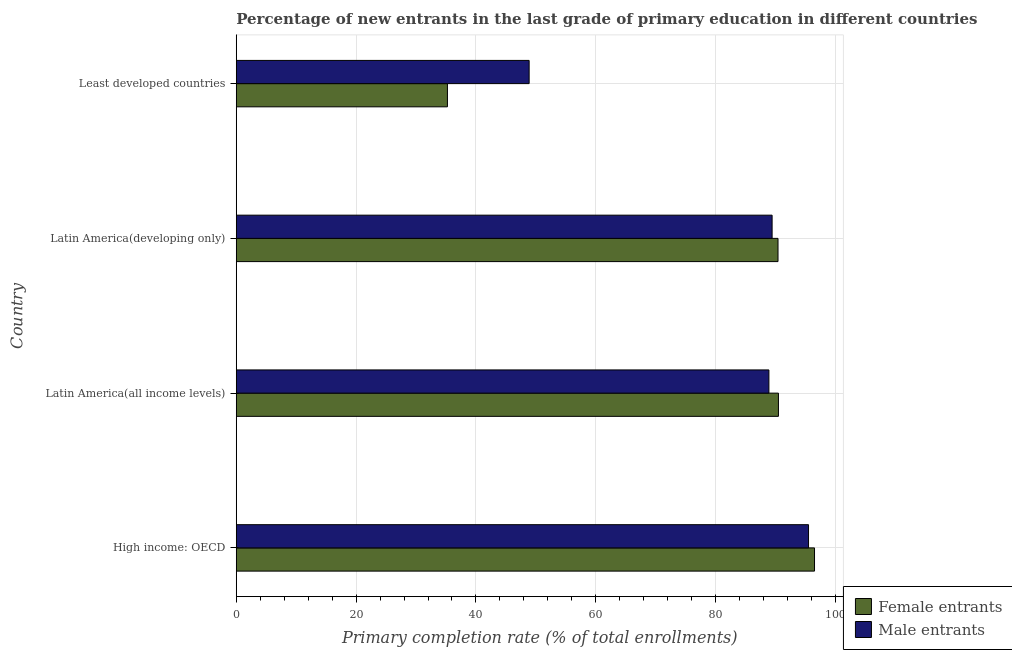How many different coloured bars are there?
Provide a succinct answer. 2. Are the number of bars on each tick of the Y-axis equal?
Your response must be concise. Yes. How many bars are there on the 1st tick from the top?
Provide a short and direct response. 2. What is the label of the 3rd group of bars from the top?
Provide a succinct answer. Latin America(all income levels). In how many cases, is the number of bars for a given country not equal to the number of legend labels?
Keep it short and to the point. 0. What is the primary completion rate of male entrants in Latin America(developing only)?
Provide a succinct answer. 89.42. Across all countries, what is the maximum primary completion rate of female entrants?
Keep it short and to the point. 96.5. Across all countries, what is the minimum primary completion rate of male entrants?
Provide a succinct answer. 48.88. In which country was the primary completion rate of female entrants maximum?
Make the answer very short. High income: OECD. In which country was the primary completion rate of female entrants minimum?
Your response must be concise. Least developed countries. What is the total primary completion rate of male entrants in the graph?
Provide a succinct answer. 322.68. What is the difference between the primary completion rate of female entrants in High income: OECD and that in Latin America(developing only)?
Give a very brief answer. 6.09. What is the difference between the primary completion rate of female entrants in High income: OECD and the primary completion rate of male entrants in Latin America(all income levels)?
Ensure brevity in your answer.  7.61. What is the average primary completion rate of male entrants per country?
Your response must be concise. 80.67. What is the difference between the primary completion rate of female entrants and primary completion rate of male entrants in Least developed countries?
Your answer should be compact. -13.63. What is the ratio of the primary completion rate of female entrants in High income: OECD to that in Latin America(developing only)?
Ensure brevity in your answer.  1.07. Is the primary completion rate of female entrants in High income: OECD less than that in Latin America(developing only)?
Keep it short and to the point. No. Is the difference between the primary completion rate of female entrants in High income: OECD and Latin America(all income levels) greater than the difference between the primary completion rate of male entrants in High income: OECD and Latin America(all income levels)?
Your answer should be compact. No. What is the difference between the highest and the second highest primary completion rate of male entrants?
Offer a terse response. 6.08. What is the difference between the highest and the lowest primary completion rate of male entrants?
Your answer should be compact. 46.62. Is the sum of the primary completion rate of female entrants in Latin America(all income levels) and Least developed countries greater than the maximum primary completion rate of male entrants across all countries?
Make the answer very short. Yes. What does the 1st bar from the top in Latin America(developing only) represents?
Your answer should be compact. Male entrants. What does the 1st bar from the bottom in Least developed countries represents?
Keep it short and to the point. Female entrants. Are all the bars in the graph horizontal?
Give a very brief answer. Yes. How many countries are there in the graph?
Offer a very short reply. 4. How many legend labels are there?
Your answer should be compact. 2. What is the title of the graph?
Make the answer very short. Percentage of new entrants in the last grade of primary education in different countries. What is the label or title of the X-axis?
Keep it short and to the point. Primary completion rate (% of total enrollments). What is the label or title of the Y-axis?
Offer a very short reply. Country. What is the Primary completion rate (% of total enrollments) of Female entrants in High income: OECD?
Give a very brief answer. 96.5. What is the Primary completion rate (% of total enrollments) of Male entrants in High income: OECD?
Offer a terse response. 95.5. What is the Primary completion rate (% of total enrollments) of Female entrants in Latin America(all income levels)?
Make the answer very short. 90.48. What is the Primary completion rate (% of total enrollments) in Male entrants in Latin America(all income levels)?
Give a very brief answer. 88.89. What is the Primary completion rate (% of total enrollments) in Female entrants in Latin America(developing only)?
Offer a very short reply. 90.4. What is the Primary completion rate (% of total enrollments) of Male entrants in Latin America(developing only)?
Keep it short and to the point. 89.42. What is the Primary completion rate (% of total enrollments) of Female entrants in Least developed countries?
Ensure brevity in your answer.  35.24. What is the Primary completion rate (% of total enrollments) in Male entrants in Least developed countries?
Ensure brevity in your answer.  48.88. Across all countries, what is the maximum Primary completion rate (% of total enrollments) of Female entrants?
Your answer should be very brief. 96.5. Across all countries, what is the maximum Primary completion rate (% of total enrollments) in Male entrants?
Your response must be concise. 95.5. Across all countries, what is the minimum Primary completion rate (% of total enrollments) of Female entrants?
Offer a terse response. 35.24. Across all countries, what is the minimum Primary completion rate (% of total enrollments) in Male entrants?
Your response must be concise. 48.88. What is the total Primary completion rate (% of total enrollments) in Female entrants in the graph?
Give a very brief answer. 312.62. What is the total Primary completion rate (% of total enrollments) of Male entrants in the graph?
Offer a very short reply. 322.68. What is the difference between the Primary completion rate (% of total enrollments) of Female entrants in High income: OECD and that in Latin America(all income levels)?
Offer a very short reply. 6.02. What is the difference between the Primary completion rate (% of total enrollments) in Male entrants in High income: OECD and that in Latin America(all income levels)?
Offer a terse response. 6.61. What is the difference between the Primary completion rate (% of total enrollments) in Female entrants in High income: OECD and that in Latin America(developing only)?
Ensure brevity in your answer.  6.09. What is the difference between the Primary completion rate (% of total enrollments) in Male entrants in High income: OECD and that in Latin America(developing only)?
Offer a terse response. 6.08. What is the difference between the Primary completion rate (% of total enrollments) in Female entrants in High income: OECD and that in Least developed countries?
Give a very brief answer. 61.26. What is the difference between the Primary completion rate (% of total enrollments) in Male entrants in High income: OECD and that in Least developed countries?
Give a very brief answer. 46.62. What is the difference between the Primary completion rate (% of total enrollments) of Female entrants in Latin America(all income levels) and that in Latin America(developing only)?
Provide a short and direct response. 0.07. What is the difference between the Primary completion rate (% of total enrollments) of Male entrants in Latin America(all income levels) and that in Latin America(developing only)?
Your response must be concise. -0.53. What is the difference between the Primary completion rate (% of total enrollments) of Female entrants in Latin America(all income levels) and that in Least developed countries?
Offer a terse response. 55.23. What is the difference between the Primary completion rate (% of total enrollments) in Male entrants in Latin America(all income levels) and that in Least developed countries?
Offer a terse response. 40.01. What is the difference between the Primary completion rate (% of total enrollments) in Female entrants in Latin America(developing only) and that in Least developed countries?
Offer a terse response. 55.16. What is the difference between the Primary completion rate (% of total enrollments) of Male entrants in Latin America(developing only) and that in Least developed countries?
Make the answer very short. 40.54. What is the difference between the Primary completion rate (% of total enrollments) of Female entrants in High income: OECD and the Primary completion rate (% of total enrollments) of Male entrants in Latin America(all income levels)?
Provide a succinct answer. 7.61. What is the difference between the Primary completion rate (% of total enrollments) in Female entrants in High income: OECD and the Primary completion rate (% of total enrollments) in Male entrants in Latin America(developing only)?
Provide a succinct answer. 7.08. What is the difference between the Primary completion rate (% of total enrollments) in Female entrants in High income: OECD and the Primary completion rate (% of total enrollments) in Male entrants in Least developed countries?
Give a very brief answer. 47.62. What is the difference between the Primary completion rate (% of total enrollments) of Female entrants in Latin America(all income levels) and the Primary completion rate (% of total enrollments) of Male entrants in Latin America(developing only)?
Your response must be concise. 1.06. What is the difference between the Primary completion rate (% of total enrollments) of Female entrants in Latin America(all income levels) and the Primary completion rate (% of total enrollments) of Male entrants in Least developed countries?
Keep it short and to the point. 41.6. What is the difference between the Primary completion rate (% of total enrollments) in Female entrants in Latin America(developing only) and the Primary completion rate (% of total enrollments) in Male entrants in Least developed countries?
Keep it short and to the point. 41.53. What is the average Primary completion rate (% of total enrollments) in Female entrants per country?
Offer a very short reply. 78.16. What is the average Primary completion rate (% of total enrollments) of Male entrants per country?
Keep it short and to the point. 80.67. What is the difference between the Primary completion rate (% of total enrollments) of Female entrants and Primary completion rate (% of total enrollments) of Male entrants in Latin America(all income levels)?
Provide a short and direct response. 1.59. What is the difference between the Primary completion rate (% of total enrollments) of Female entrants and Primary completion rate (% of total enrollments) of Male entrants in Latin America(developing only)?
Give a very brief answer. 0.98. What is the difference between the Primary completion rate (% of total enrollments) in Female entrants and Primary completion rate (% of total enrollments) in Male entrants in Least developed countries?
Your answer should be very brief. -13.63. What is the ratio of the Primary completion rate (% of total enrollments) in Female entrants in High income: OECD to that in Latin America(all income levels)?
Provide a short and direct response. 1.07. What is the ratio of the Primary completion rate (% of total enrollments) in Male entrants in High income: OECD to that in Latin America(all income levels)?
Ensure brevity in your answer.  1.07. What is the ratio of the Primary completion rate (% of total enrollments) in Female entrants in High income: OECD to that in Latin America(developing only)?
Offer a terse response. 1.07. What is the ratio of the Primary completion rate (% of total enrollments) of Male entrants in High income: OECD to that in Latin America(developing only)?
Ensure brevity in your answer.  1.07. What is the ratio of the Primary completion rate (% of total enrollments) of Female entrants in High income: OECD to that in Least developed countries?
Your answer should be very brief. 2.74. What is the ratio of the Primary completion rate (% of total enrollments) of Male entrants in High income: OECD to that in Least developed countries?
Offer a very short reply. 1.95. What is the ratio of the Primary completion rate (% of total enrollments) of Female entrants in Latin America(all income levels) to that in Latin America(developing only)?
Keep it short and to the point. 1. What is the ratio of the Primary completion rate (% of total enrollments) in Male entrants in Latin America(all income levels) to that in Latin America(developing only)?
Provide a succinct answer. 0.99. What is the ratio of the Primary completion rate (% of total enrollments) in Female entrants in Latin America(all income levels) to that in Least developed countries?
Your answer should be compact. 2.57. What is the ratio of the Primary completion rate (% of total enrollments) in Male entrants in Latin America(all income levels) to that in Least developed countries?
Provide a succinct answer. 1.82. What is the ratio of the Primary completion rate (% of total enrollments) in Female entrants in Latin America(developing only) to that in Least developed countries?
Provide a short and direct response. 2.57. What is the ratio of the Primary completion rate (% of total enrollments) of Male entrants in Latin America(developing only) to that in Least developed countries?
Offer a very short reply. 1.83. What is the difference between the highest and the second highest Primary completion rate (% of total enrollments) of Female entrants?
Your answer should be very brief. 6.02. What is the difference between the highest and the second highest Primary completion rate (% of total enrollments) in Male entrants?
Keep it short and to the point. 6.08. What is the difference between the highest and the lowest Primary completion rate (% of total enrollments) in Female entrants?
Offer a terse response. 61.26. What is the difference between the highest and the lowest Primary completion rate (% of total enrollments) of Male entrants?
Make the answer very short. 46.62. 